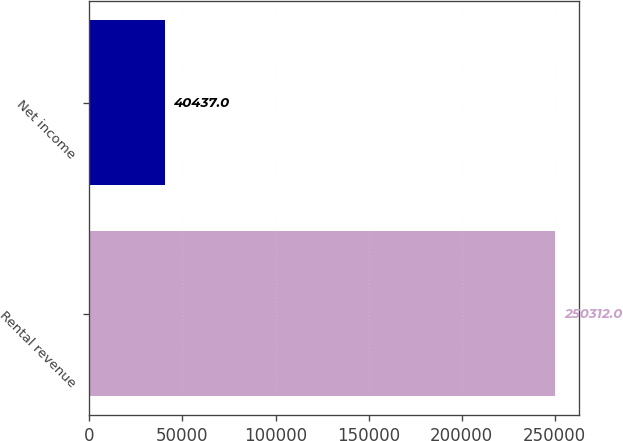<chart> <loc_0><loc_0><loc_500><loc_500><bar_chart><fcel>Rental revenue<fcel>Net income<nl><fcel>250312<fcel>40437<nl></chart> 